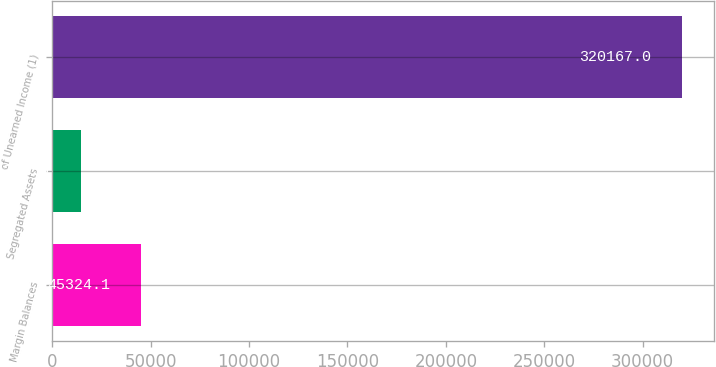Convert chart to OTSL. <chart><loc_0><loc_0><loc_500><loc_500><bar_chart><fcel>Margin Balances<fcel>Segregated Assets<fcel>of Unearned Income (1)<nl><fcel>45324.1<fcel>14786<fcel>320167<nl></chart> 